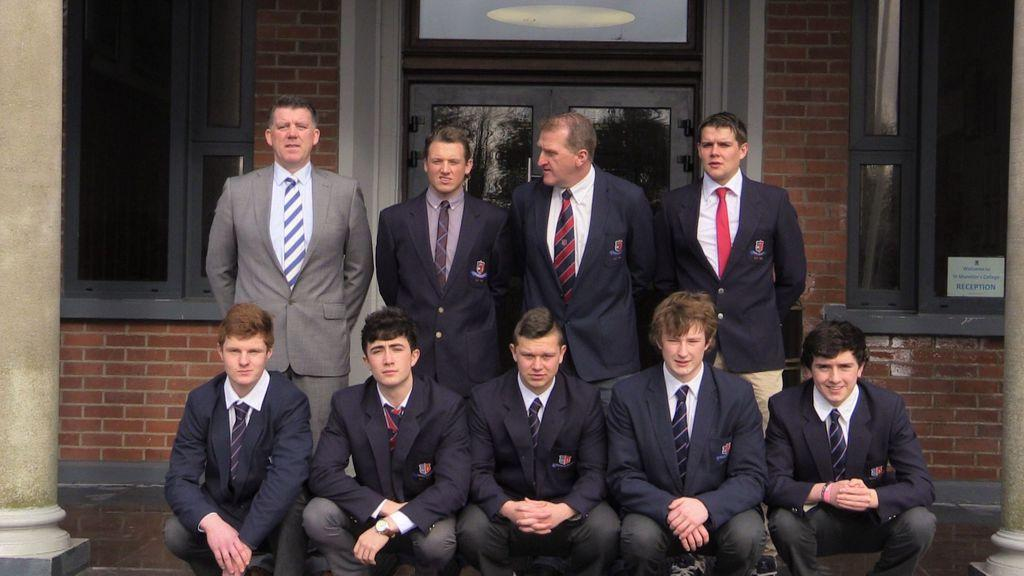What type of clothing are the people wearing in the image? The people are wearing navy-blue, black, and grey blazers in the image. What can be seen in the background of the image? There is a building in the image, along with windows and a wall. Are the people in the image using their muscles to perform a specific task? There is no indication in the image that the people are using their muscles for any specific task. 